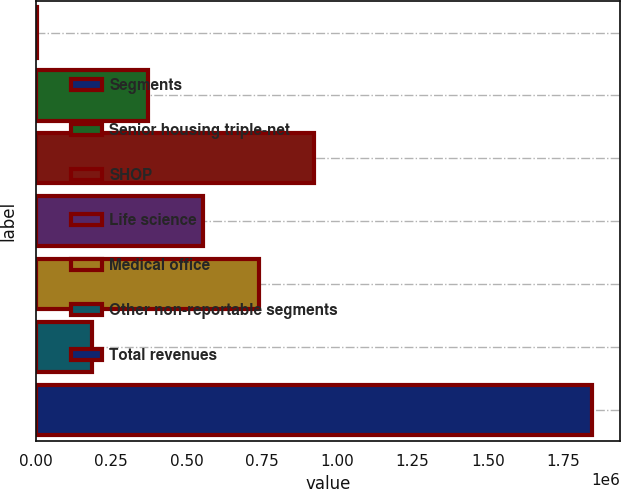Convert chart to OTSL. <chart><loc_0><loc_0><loc_500><loc_500><bar_chart><fcel>Segments<fcel>Senior housing triple-net<fcel>SHOP<fcel>Life science<fcel>Medical office<fcel>Other non-reportable segments<fcel>Total revenues<nl><fcel>2018<fcel>370952<fcel>924354<fcel>555419<fcel>739886<fcel>186485<fcel>1.84669e+06<nl></chart> 